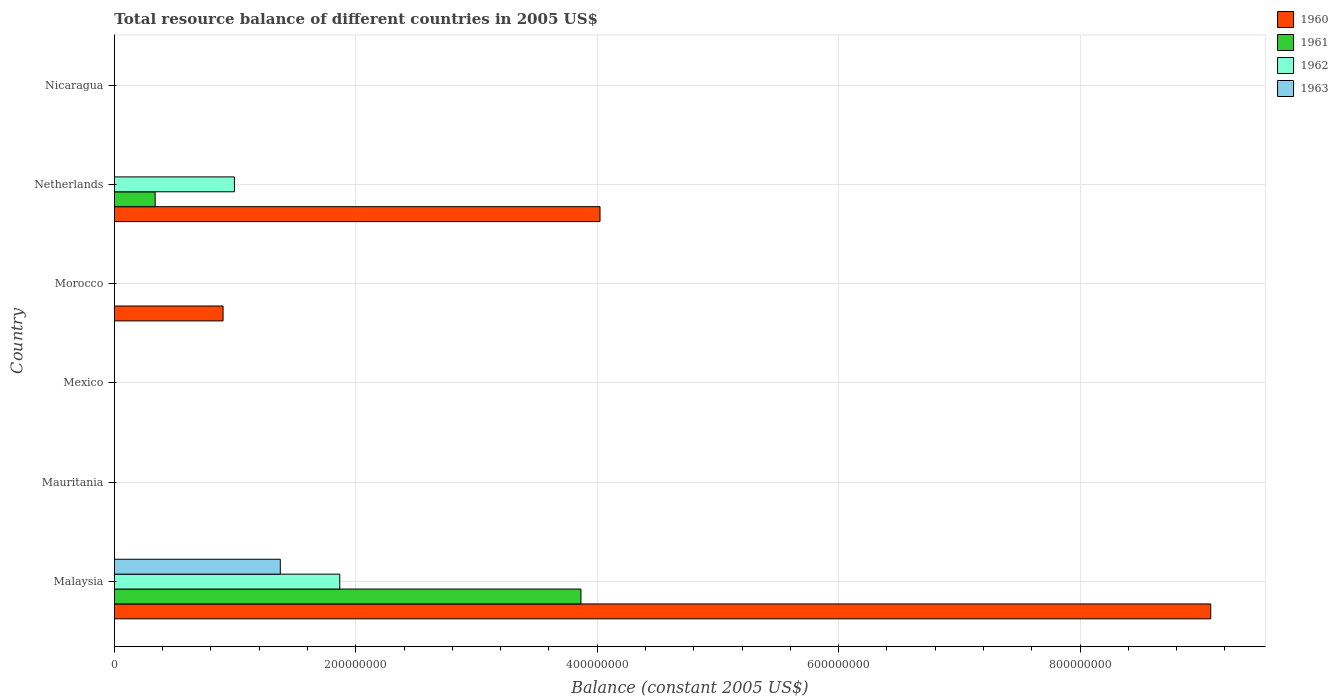How many different coloured bars are there?
Keep it short and to the point. 4. Are the number of bars per tick equal to the number of legend labels?
Offer a terse response. No. Are the number of bars on each tick of the Y-axis equal?
Provide a succinct answer. No. How many bars are there on the 4th tick from the bottom?
Ensure brevity in your answer.  1. What is the label of the 2nd group of bars from the top?
Provide a succinct answer. Netherlands. Across all countries, what is the maximum total resource balance in 1961?
Provide a succinct answer. 3.87e+08. Across all countries, what is the minimum total resource balance in 1963?
Offer a very short reply. 0. In which country was the total resource balance in 1963 maximum?
Provide a succinct answer. Malaysia. What is the total total resource balance in 1963 in the graph?
Provide a succinct answer. 1.37e+08. What is the difference between the total resource balance in 1960 in Morocco and that in Netherlands?
Your response must be concise. -3.12e+08. What is the difference between the total resource balance in 1962 in Malaysia and the total resource balance in 1961 in Nicaragua?
Offer a terse response. 1.87e+08. What is the average total resource balance in 1960 per country?
Offer a terse response. 2.33e+08. What is the difference between the total resource balance in 1960 and total resource balance in 1962 in Malaysia?
Make the answer very short. 7.22e+08. In how many countries, is the total resource balance in 1961 greater than 440000000 US$?
Offer a terse response. 0. What is the ratio of the total resource balance in 1961 in Malaysia to that in Netherlands?
Your response must be concise. 11.45. What is the difference between the highest and the second highest total resource balance in 1960?
Offer a terse response. 5.06e+08. What is the difference between the highest and the lowest total resource balance in 1960?
Offer a terse response. 9.08e+08. In how many countries, is the total resource balance in 1963 greater than the average total resource balance in 1963 taken over all countries?
Offer a terse response. 1. Is it the case that in every country, the sum of the total resource balance in 1962 and total resource balance in 1963 is greater than the total resource balance in 1960?
Provide a short and direct response. No. How many bars are there?
Give a very brief answer. 8. How many countries are there in the graph?
Provide a succinct answer. 6. What is the difference between two consecutive major ticks on the X-axis?
Offer a very short reply. 2.00e+08. Does the graph contain grids?
Offer a terse response. Yes. What is the title of the graph?
Make the answer very short. Total resource balance of different countries in 2005 US$. Does "1972" appear as one of the legend labels in the graph?
Your answer should be compact. No. What is the label or title of the X-axis?
Provide a short and direct response. Balance (constant 2005 US$). What is the label or title of the Y-axis?
Offer a very short reply. Country. What is the Balance (constant 2005 US$) in 1960 in Malaysia?
Your answer should be very brief. 9.08e+08. What is the Balance (constant 2005 US$) of 1961 in Malaysia?
Your response must be concise. 3.87e+08. What is the Balance (constant 2005 US$) in 1962 in Malaysia?
Ensure brevity in your answer.  1.87e+08. What is the Balance (constant 2005 US$) of 1963 in Malaysia?
Your answer should be compact. 1.37e+08. What is the Balance (constant 2005 US$) in 1960 in Mauritania?
Your answer should be compact. 0. What is the Balance (constant 2005 US$) of 1961 in Mauritania?
Your answer should be compact. 0. What is the Balance (constant 2005 US$) of 1963 in Mauritania?
Keep it short and to the point. 0. What is the Balance (constant 2005 US$) in 1960 in Mexico?
Make the answer very short. 0. What is the Balance (constant 2005 US$) in 1960 in Morocco?
Give a very brief answer. 9.00e+07. What is the Balance (constant 2005 US$) of 1961 in Morocco?
Ensure brevity in your answer.  0. What is the Balance (constant 2005 US$) of 1963 in Morocco?
Your answer should be compact. 0. What is the Balance (constant 2005 US$) in 1960 in Netherlands?
Provide a short and direct response. 4.02e+08. What is the Balance (constant 2005 US$) of 1961 in Netherlands?
Keep it short and to the point. 3.37e+07. What is the Balance (constant 2005 US$) in 1962 in Netherlands?
Provide a short and direct response. 9.94e+07. What is the Balance (constant 2005 US$) of 1960 in Nicaragua?
Your response must be concise. 0. What is the Balance (constant 2005 US$) in 1963 in Nicaragua?
Provide a succinct answer. 0. Across all countries, what is the maximum Balance (constant 2005 US$) of 1960?
Keep it short and to the point. 9.08e+08. Across all countries, what is the maximum Balance (constant 2005 US$) in 1961?
Your answer should be compact. 3.87e+08. Across all countries, what is the maximum Balance (constant 2005 US$) of 1962?
Your answer should be compact. 1.87e+08. Across all countries, what is the maximum Balance (constant 2005 US$) in 1963?
Keep it short and to the point. 1.37e+08. Across all countries, what is the minimum Balance (constant 2005 US$) in 1960?
Your answer should be compact. 0. Across all countries, what is the minimum Balance (constant 2005 US$) in 1963?
Ensure brevity in your answer.  0. What is the total Balance (constant 2005 US$) in 1960 in the graph?
Provide a succinct answer. 1.40e+09. What is the total Balance (constant 2005 US$) in 1961 in the graph?
Ensure brevity in your answer.  4.20e+08. What is the total Balance (constant 2005 US$) of 1962 in the graph?
Offer a terse response. 2.86e+08. What is the total Balance (constant 2005 US$) in 1963 in the graph?
Provide a short and direct response. 1.37e+08. What is the difference between the Balance (constant 2005 US$) in 1960 in Malaysia and that in Morocco?
Your answer should be very brief. 8.18e+08. What is the difference between the Balance (constant 2005 US$) of 1960 in Malaysia and that in Netherlands?
Provide a succinct answer. 5.06e+08. What is the difference between the Balance (constant 2005 US$) in 1961 in Malaysia and that in Netherlands?
Provide a succinct answer. 3.53e+08. What is the difference between the Balance (constant 2005 US$) of 1962 in Malaysia and that in Netherlands?
Provide a short and direct response. 8.73e+07. What is the difference between the Balance (constant 2005 US$) of 1960 in Morocco and that in Netherlands?
Offer a very short reply. -3.12e+08. What is the difference between the Balance (constant 2005 US$) of 1960 in Malaysia and the Balance (constant 2005 US$) of 1961 in Netherlands?
Offer a terse response. 8.75e+08. What is the difference between the Balance (constant 2005 US$) in 1960 in Malaysia and the Balance (constant 2005 US$) in 1962 in Netherlands?
Make the answer very short. 8.09e+08. What is the difference between the Balance (constant 2005 US$) in 1961 in Malaysia and the Balance (constant 2005 US$) in 1962 in Netherlands?
Make the answer very short. 2.87e+08. What is the difference between the Balance (constant 2005 US$) of 1960 in Morocco and the Balance (constant 2005 US$) of 1961 in Netherlands?
Make the answer very short. 5.63e+07. What is the difference between the Balance (constant 2005 US$) in 1960 in Morocco and the Balance (constant 2005 US$) in 1962 in Netherlands?
Keep it short and to the point. -9.42e+06. What is the average Balance (constant 2005 US$) in 1960 per country?
Provide a succinct answer. 2.33e+08. What is the average Balance (constant 2005 US$) of 1961 per country?
Keep it short and to the point. 7.00e+07. What is the average Balance (constant 2005 US$) of 1962 per country?
Ensure brevity in your answer.  4.77e+07. What is the average Balance (constant 2005 US$) of 1963 per country?
Keep it short and to the point. 2.29e+07. What is the difference between the Balance (constant 2005 US$) of 1960 and Balance (constant 2005 US$) of 1961 in Malaysia?
Ensure brevity in your answer.  5.22e+08. What is the difference between the Balance (constant 2005 US$) of 1960 and Balance (constant 2005 US$) of 1962 in Malaysia?
Offer a terse response. 7.22e+08. What is the difference between the Balance (constant 2005 US$) in 1960 and Balance (constant 2005 US$) in 1963 in Malaysia?
Give a very brief answer. 7.71e+08. What is the difference between the Balance (constant 2005 US$) of 1961 and Balance (constant 2005 US$) of 1962 in Malaysia?
Make the answer very short. 2.00e+08. What is the difference between the Balance (constant 2005 US$) of 1961 and Balance (constant 2005 US$) of 1963 in Malaysia?
Your response must be concise. 2.49e+08. What is the difference between the Balance (constant 2005 US$) in 1962 and Balance (constant 2005 US$) in 1963 in Malaysia?
Give a very brief answer. 4.93e+07. What is the difference between the Balance (constant 2005 US$) in 1960 and Balance (constant 2005 US$) in 1961 in Netherlands?
Your response must be concise. 3.69e+08. What is the difference between the Balance (constant 2005 US$) of 1960 and Balance (constant 2005 US$) of 1962 in Netherlands?
Offer a very short reply. 3.03e+08. What is the difference between the Balance (constant 2005 US$) of 1961 and Balance (constant 2005 US$) of 1962 in Netherlands?
Ensure brevity in your answer.  -6.57e+07. What is the ratio of the Balance (constant 2005 US$) in 1960 in Malaysia to that in Morocco?
Provide a short and direct response. 10.09. What is the ratio of the Balance (constant 2005 US$) of 1960 in Malaysia to that in Netherlands?
Offer a terse response. 2.26. What is the ratio of the Balance (constant 2005 US$) in 1961 in Malaysia to that in Netherlands?
Your answer should be compact. 11.45. What is the ratio of the Balance (constant 2005 US$) in 1962 in Malaysia to that in Netherlands?
Offer a terse response. 1.88. What is the ratio of the Balance (constant 2005 US$) of 1960 in Morocco to that in Netherlands?
Provide a short and direct response. 0.22. What is the difference between the highest and the second highest Balance (constant 2005 US$) of 1960?
Your answer should be compact. 5.06e+08. What is the difference between the highest and the lowest Balance (constant 2005 US$) of 1960?
Provide a succinct answer. 9.08e+08. What is the difference between the highest and the lowest Balance (constant 2005 US$) in 1961?
Make the answer very short. 3.87e+08. What is the difference between the highest and the lowest Balance (constant 2005 US$) of 1962?
Provide a short and direct response. 1.87e+08. What is the difference between the highest and the lowest Balance (constant 2005 US$) of 1963?
Your response must be concise. 1.37e+08. 